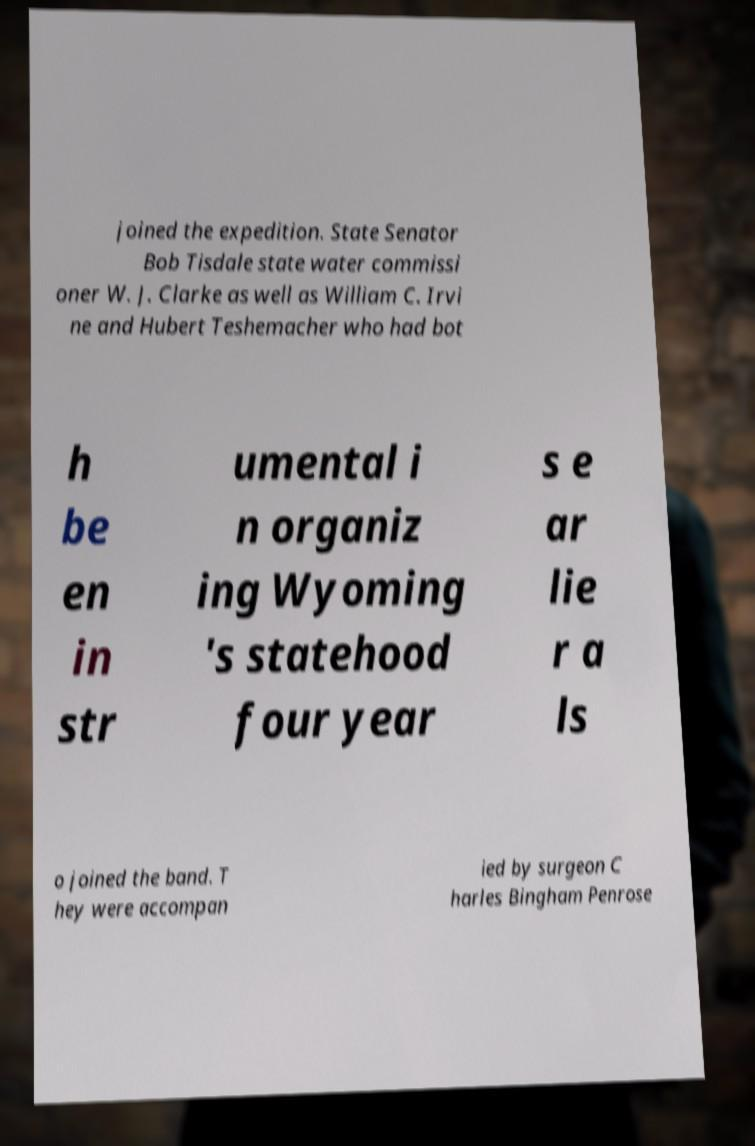For documentation purposes, I need the text within this image transcribed. Could you provide that? joined the expedition. State Senator Bob Tisdale state water commissi oner W. J. Clarke as well as William C. Irvi ne and Hubert Teshemacher who had bot h be en in str umental i n organiz ing Wyoming 's statehood four year s e ar lie r a ls o joined the band. T hey were accompan ied by surgeon C harles Bingham Penrose 